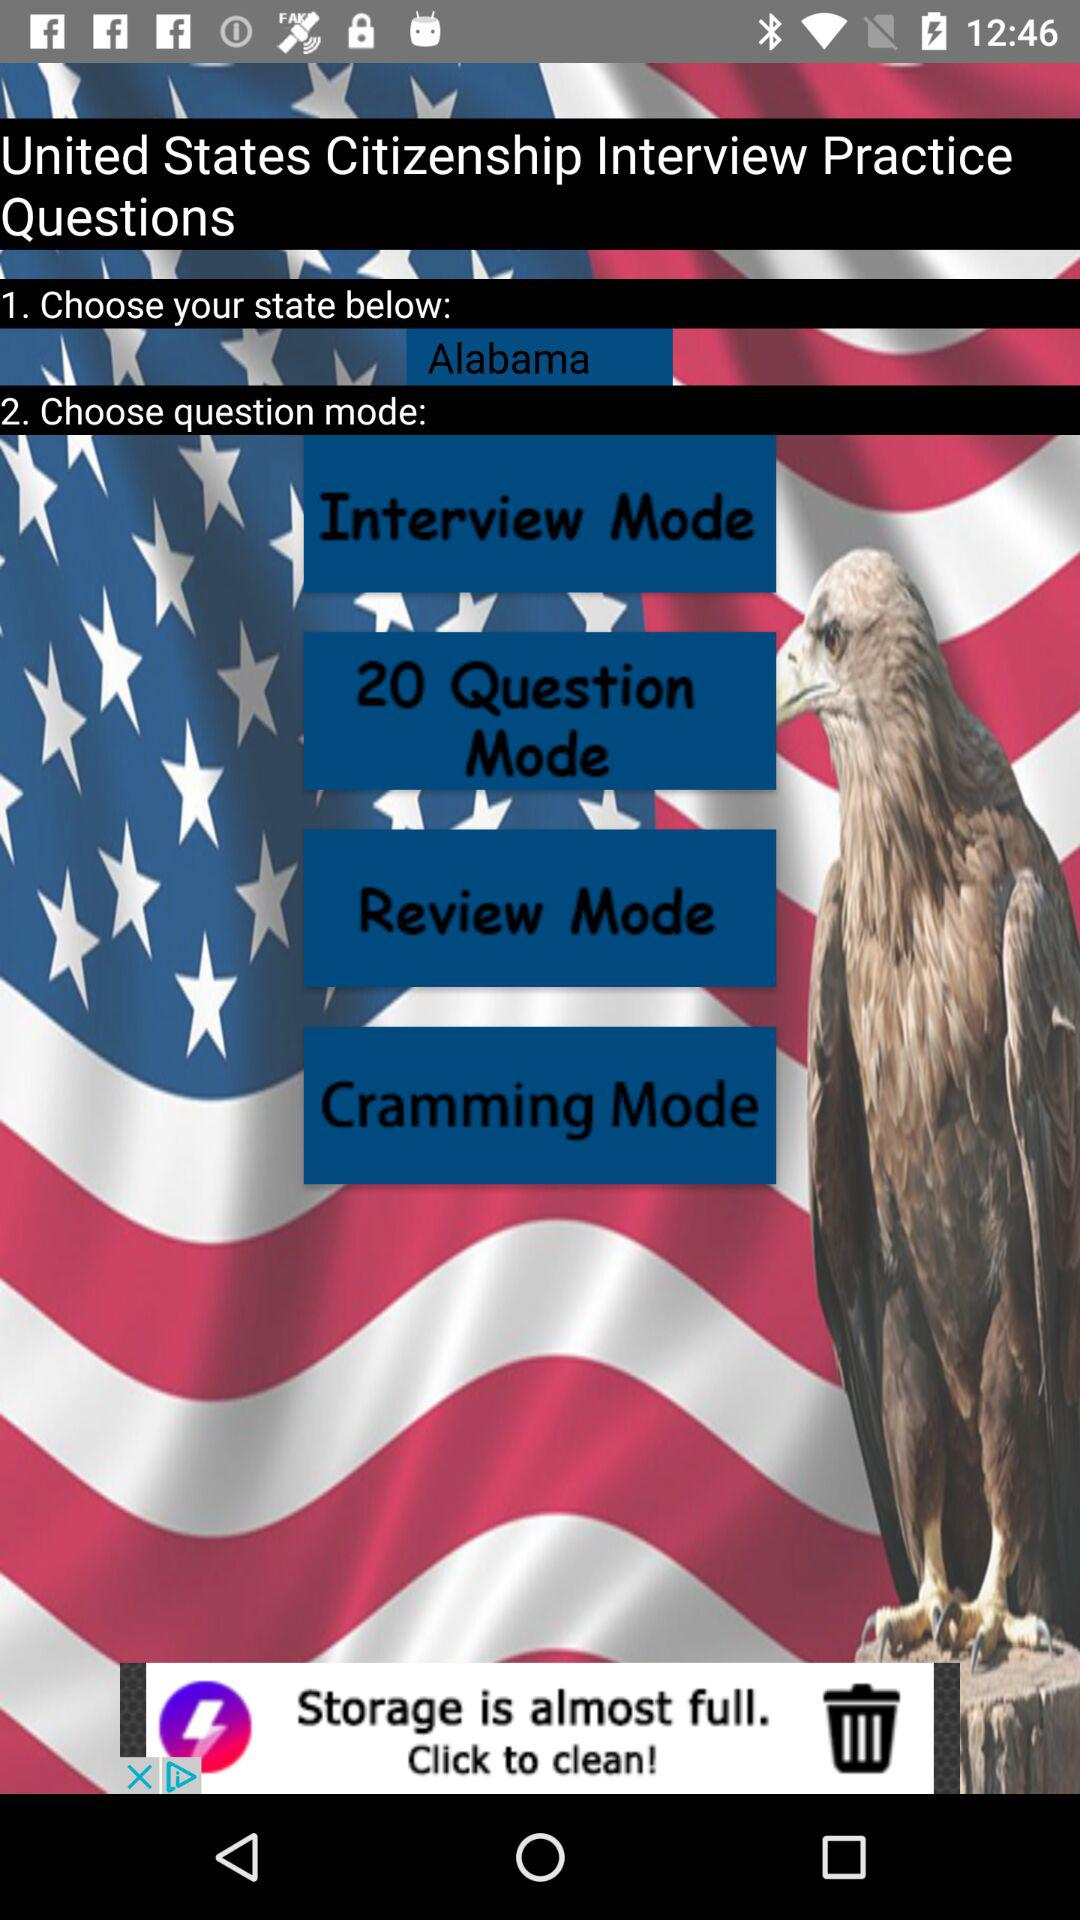How many numbers in question mode are there? There are 20 question modes. 